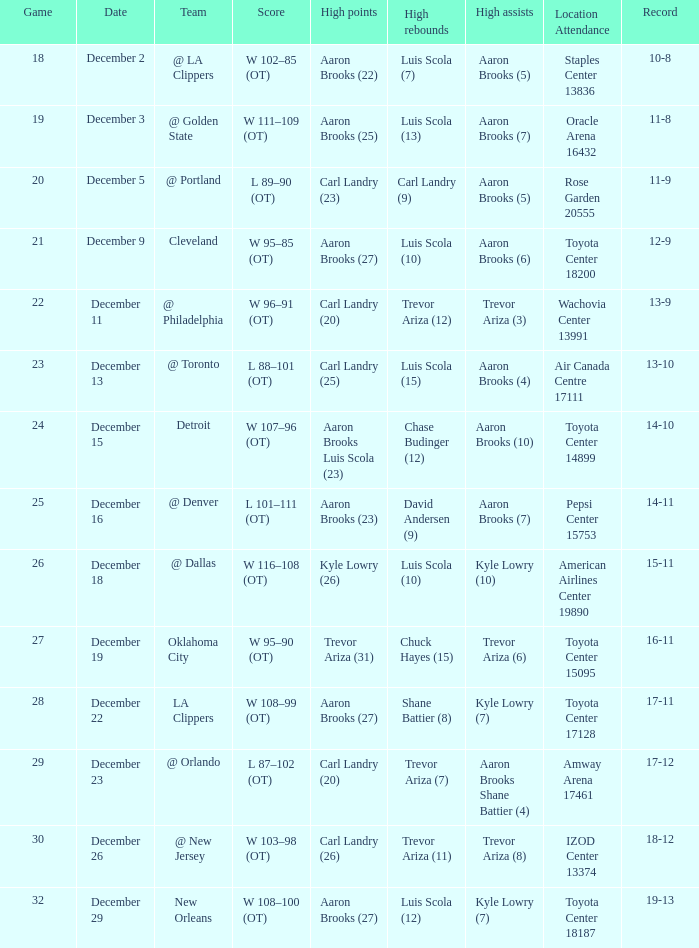In which location was the game where carl landry (25) achieved the most points played? Air Canada Centre 17111. Could you parse the entire table? {'header': ['Game', 'Date', 'Team', 'Score', 'High points', 'High rebounds', 'High assists', 'Location Attendance', 'Record'], 'rows': [['18', 'December 2', '@ LA Clippers', 'W 102–85 (OT)', 'Aaron Brooks (22)', 'Luis Scola (7)', 'Aaron Brooks (5)', 'Staples Center 13836', '10-8'], ['19', 'December 3', '@ Golden State', 'W 111–109 (OT)', 'Aaron Brooks (25)', 'Luis Scola (13)', 'Aaron Brooks (7)', 'Oracle Arena 16432', '11-8'], ['20', 'December 5', '@ Portland', 'L 89–90 (OT)', 'Carl Landry (23)', 'Carl Landry (9)', 'Aaron Brooks (5)', 'Rose Garden 20555', '11-9'], ['21', 'December 9', 'Cleveland', 'W 95–85 (OT)', 'Aaron Brooks (27)', 'Luis Scola (10)', 'Aaron Brooks (6)', 'Toyota Center 18200', '12-9'], ['22', 'December 11', '@ Philadelphia', 'W 96–91 (OT)', 'Carl Landry (20)', 'Trevor Ariza (12)', 'Trevor Ariza (3)', 'Wachovia Center 13991', '13-9'], ['23', 'December 13', '@ Toronto', 'L 88–101 (OT)', 'Carl Landry (25)', 'Luis Scola (15)', 'Aaron Brooks (4)', 'Air Canada Centre 17111', '13-10'], ['24', 'December 15', 'Detroit', 'W 107–96 (OT)', 'Aaron Brooks Luis Scola (23)', 'Chase Budinger (12)', 'Aaron Brooks (10)', 'Toyota Center 14899', '14-10'], ['25', 'December 16', '@ Denver', 'L 101–111 (OT)', 'Aaron Brooks (23)', 'David Andersen (9)', 'Aaron Brooks (7)', 'Pepsi Center 15753', '14-11'], ['26', 'December 18', '@ Dallas', 'W 116–108 (OT)', 'Kyle Lowry (26)', 'Luis Scola (10)', 'Kyle Lowry (10)', 'American Airlines Center 19890', '15-11'], ['27', 'December 19', 'Oklahoma City', 'W 95–90 (OT)', 'Trevor Ariza (31)', 'Chuck Hayes (15)', 'Trevor Ariza (6)', 'Toyota Center 15095', '16-11'], ['28', 'December 22', 'LA Clippers', 'W 108–99 (OT)', 'Aaron Brooks (27)', 'Shane Battier (8)', 'Kyle Lowry (7)', 'Toyota Center 17128', '17-11'], ['29', 'December 23', '@ Orlando', 'L 87–102 (OT)', 'Carl Landry (20)', 'Trevor Ariza (7)', 'Aaron Brooks Shane Battier (4)', 'Amway Arena 17461', '17-12'], ['30', 'December 26', '@ New Jersey', 'W 103–98 (OT)', 'Carl Landry (26)', 'Trevor Ariza (11)', 'Trevor Ariza (8)', 'IZOD Center 13374', '18-12'], ['32', 'December 29', 'New Orleans', 'W 108–100 (OT)', 'Aaron Brooks (27)', 'Luis Scola (12)', 'Kyle Lowry (7)', 'Toyota Center 18187', '19-13']]} 